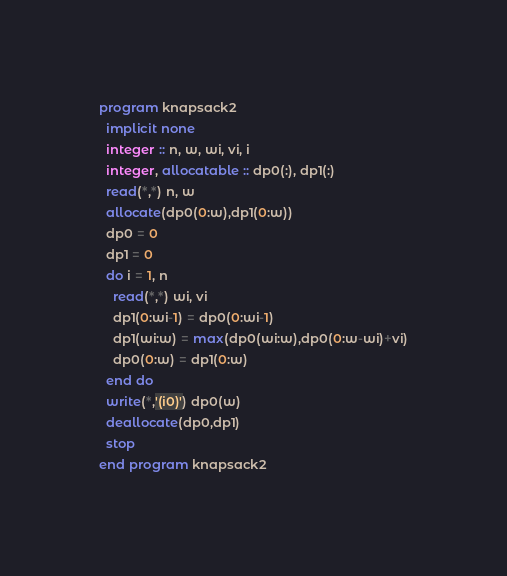Convert code to text. <code><loc_0><loc_0><loc_500><loc_500><_FORTRAN_>program knapsack2
  implicit none
  integer :: n, w, wi, vi, i
  integer, allocatable :: dp0(:), dp1(:)
  read(*,*) n, w
  allocate(dp0(0:w),dp1(0:w))
  dp0 = 0
  dp1 = 0
  do i = 1, n
    read(*,*) wi, vi
    dp1(0:wi-1) = dp0(0:wi-1)
    dp1(wi:w) = max(dp0(wi:w),dp0(0:w-wi)+vi)
    dp0(0:w) = dp1(0:w)
  end do
  write(*,'(i0)') dp0(w)
  deallocate(dp0,dp1)
  stop
end program knapsack2</code> 